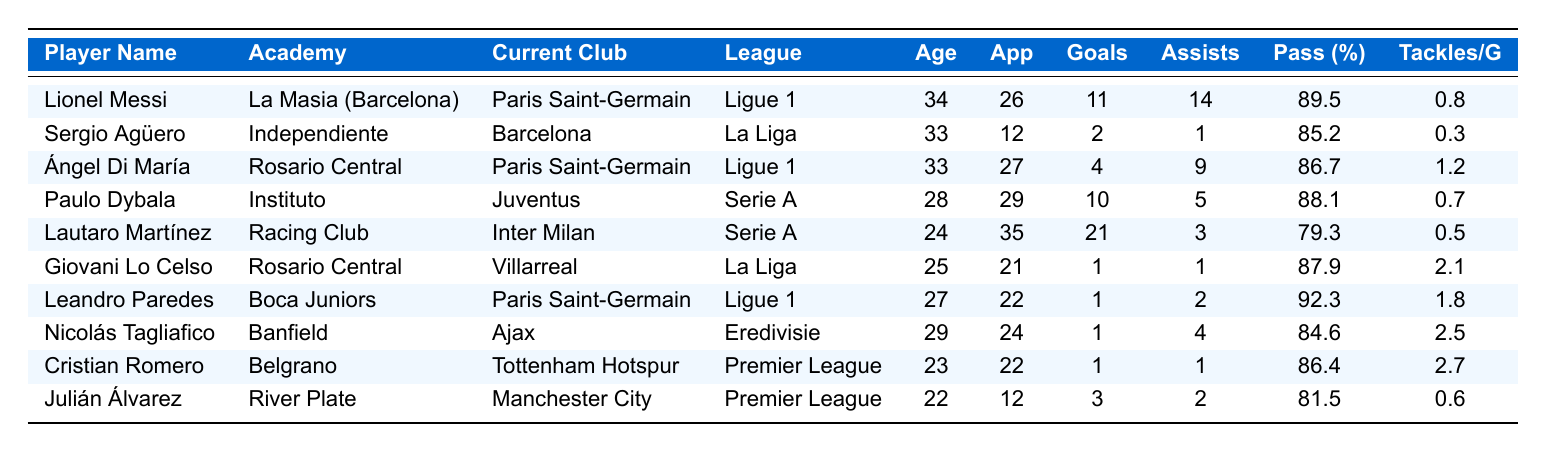What is the current club of Lionel Messi? Looking at the table, Lionel Messi is listed under the "Current Club" column where it states "Paris Saint-Germain."
Answer: Paris Saint-Germain Who has the highest pass accuracy percentage among these players? By reviewing the "Pass Accuracy (%)" column, Leandro Paredes has the highest value at 92.3%.
Answer: Leandro Paredes How many total goals have been scored by Lautaro Martínez and Paulo Dybala combined? Adding the goals from Lautaro Martínez (21) and Paulo Dybala (10) gives: 21 + 10 = 31.
Answer: 31 Is Sergio Agüero younger than 34 years old? According to the "Age" column, Sergio Agüero is 33 years old, which is younger than 34.
Answer: Yes What is the average number of assists made by players in the Ligue 1? The players in Ligue 1 are Lionel Messi, Ángel Di María, and Leandro Paredes with assists of 14, 9, and 2 respectively; adding those (14 + 9 + 2 = 25) and dividing by 3 gives an average of 25/3 ≈ 8.33.
Answer: 8.33 Which player has the highest tackles per game, and how many does he average? Checking the "Tackles per Game" column, Nicolás Tagliafico averages 2.5 tackles per game, which is the highest among the players listed.
Answer: Nicolás Tagliafico, 2.5 What is the total number of appearances made by Cristian Romero and Julián Álvarez? From the "Appearances" column, Cristian Romero made 22 appearances and Julián Álvarez made 12; adding them gives 22 + 12 = 34.
Answer: 34 Does Leandro Paredes play in the Premier League? Looking at the "League" column, Leandro Paredes is listed in Ligue 1, not the Premier League.
Answer: No What percentage of players are above the age of 30? From the table, there are 3 players (Sergio Agüero, Ángel Di María, and Lionel Messi) above 30 years old out of 10 total players, which gives 3/10 = 0.3 or 30%.
Answer: 30% What is the difference in the number of goals between Lautaro Martínez and Ángel Di María? Lautaro Martínez scored 21 goals while Ángel Di María scored 4; thus, the difference is 21 - 4 = 17.
Answer: 17 